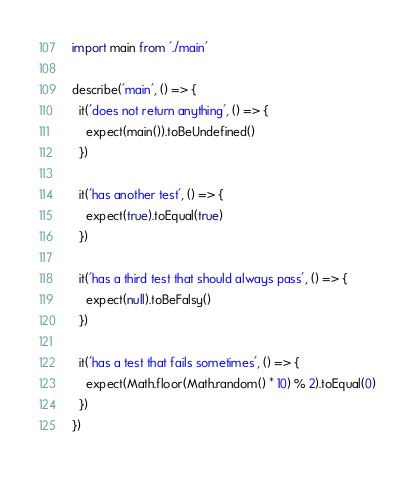<code> <loc_0><loc_0><loc_500><loc_500><_TypeScript_>import main from './main'

describe('main', () => {
  it('does not return anything', () => {
    expect(main()).toBeUndefined()
  })

  it('has another test', () => {
    expect(true).toEqual(true)
  })

  it('has a third test that should always pass', () => {
    expect(null).toBeFalsy()
  })

  it('has a test that fails sometimes', () => {
    expect(Math.floor(Math.random() * 10) % 2).toEqual(0)
  })
})
</code> 